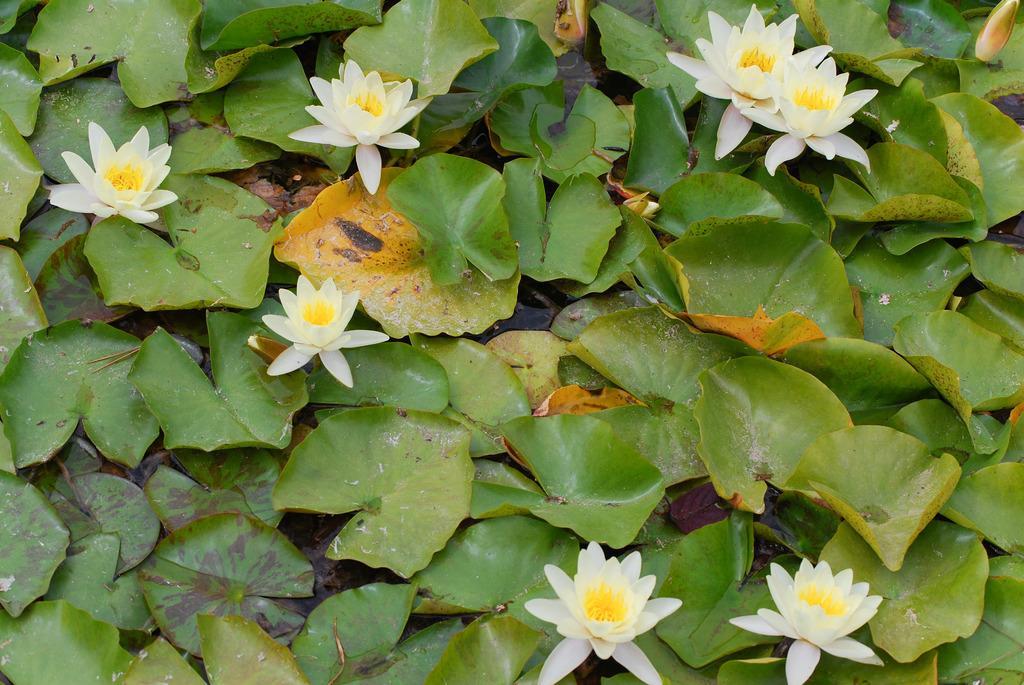Can you describe this image briefly? In this picture we can see few flowers, leaves and water. 